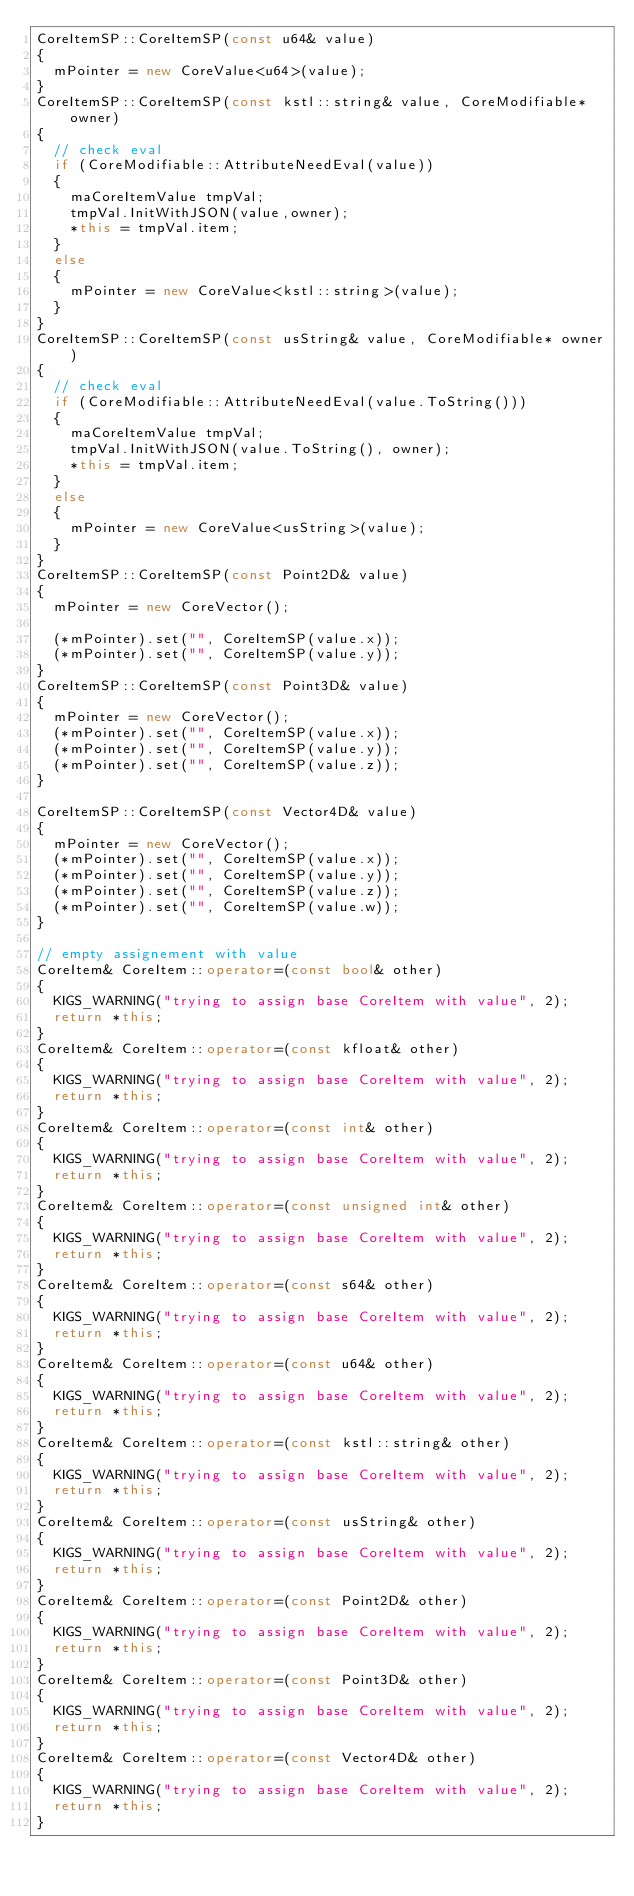<code> <loc_0><loc_0><loc_500><loc_500><_C++_>CoreItemSP::CoreItemSP(const u64& value)
{
	mPointer = new CoreValue<u64>(value);
}
CoreItemSP::CoreItemSP(const kstl::string& value, CoreModifiable* owner)
{
	// check eval
	if (CoreModifiable::AttributeNeedEval(value))
	{
		maCoreItemValue	tmpVal;
		tmpVal.InitWithJSON(value,owner);
		*this = tmpVal.item;
	}
	else
	{
		mPointer = new CoreValue<kstl::string>(value);
	}
}
CoreItemSP::CoreItemSP(const usString& value, CoreModifiable* owner)
{
	// check eval
	if (CoreModifiable::AttributeNeedEval(value.ToString()))
	{
		maCoreItemValue	tmpVal;
		tmpVal.InitWithJSON(value.ToString(), owner);
		*this = tmpVal.item;
	}
	else
	{
		mPointer = new CoreValue<usString>(value);
	}
}
CoreItemSP::CoreItemSP(const Point2D& value)
{
	mPointer = new CoreVector();

	(*mPointer).set("", CoreItemSP(value.x));
	(*mPointer).set("", CoreItemSP(value.y));
}
CoreItemSP::CoreItemSP(const Point3D& value)
{
	mPointer = new CoreVector();
	(*mPointer).set("", CoreItemSP(value.x));
	(*mPointer).set("", CoreItemSP(value.y));
	(*mPointer).set("", CoreItemSP(value.z));
}

CoreItemSP::CoreItemSP(const Vector4D& value)
{
	mPointer = new CoreVector();
	(*mPointer).set("", CoreItemSP(value.x));
	(*mPointer).set("", CoreItemSP(value.y));
	(*mPointer).set("", CoreItemSP(value.z));
	(*mPointer).set("", CoreItemSP(value.w));
}

// empty assignement with value
CoreItem& CoreItem::operator=(const bool& other)
{
	KIGS_WARNING("trying to assign base CoreItem with value", 2);
	return *this;
}
CoreItem& CoreItem::operator=(const kfloat& other)
{
	KIGS_WARNING("trying to assign base CoreItem with value", 2);
	return *this;
}
CoreItem& CoreItem::operator=(const int& other)
{
	KIGS_WARNING("trying to assign base CoreItem with value", 2);
	return *this;
}
CoreItem& CoreItem::operator=(const unsigned int& other)
{
	KIGS_WARNING("trying to assign base CoreItem with value", 2);
	return *this;
}
CoreItem& CoreItem::operator=(const s64& other)
{
	KIGS_WARNING("trying to assign base CoreItem with value", 2);
	return *this;
}
CoreItem& CoreItem::operator=(const u64& other)
{
	KIGS_WARNING("trying to assign base CoreItem with value", 2);
	return *this;
}
CoreItem& CoreItem::operator=(const kstl::string& other)
{
	KIGS_WARNING("trying to assign base CoreItem with value", 2);
	return *this;
}
CoreItem& CoreItem::operator=(const usString& other)
{
	KIGS_WARNING("trying to assign base CoreItem with value", 2);
	return *this;
}
CoreItem& CoreItem::operator=(const Point2D& other)
{
	KIGS_WARNING("trying to assign base CoreItem with value", 2);
	return *this;
}
CoreItem& CoreItem::operator=(const Point3D& other)
{
	KIGS_WARNING("trying to assign base CoreItem with value", 2);
	return *this;
}
CoreItem& CoreItem::operator=(const Vector4D& other)
{
	KIGS_WARNING("trying to assign base CoreItem with value", 2);
	return *this;
}
</code> 